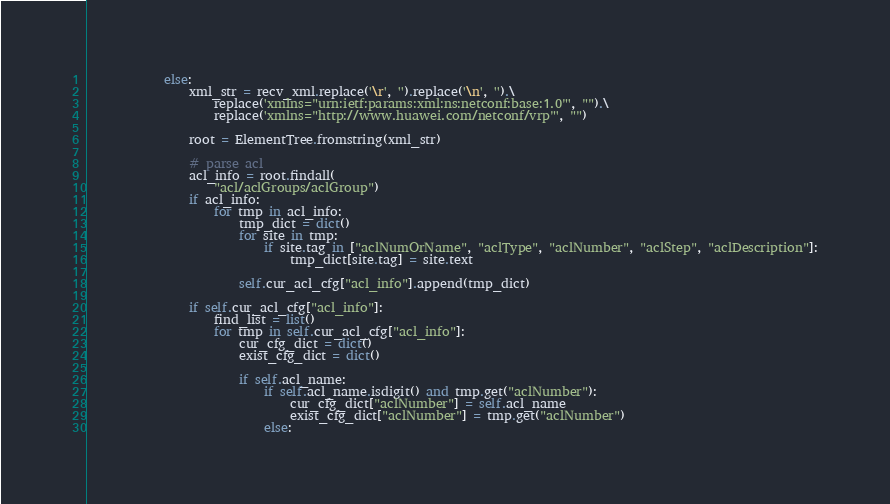Convert code to text. <code><loc_0><loc_0><loc_500><loc_500><_Python_>            else:
                xml_str = recv_xml.replace('\r', '').replace('\n', '').\
                    replace('xmlns="urn:ietf:params:xml:ns:netconf:base:1.0"', "").\
                    replace('xmlns="http://www.huawei.com/netconf/vrp"', "")

                root = ElementTree.fromstring(xml_str)

                # parse acl
                acl_info = root.findall(
                    "acl/aclGroups/aclGroup")
                if acl_info:
                    for tmp in acl_info:
                        tmp_dict = dict()
                        for site in tmp:
                            if site.tag in ["aclNumOrName", "aclType", "aclNumber", "aclStep", "aclDescription"]:
                                tmp_dict[site.tag] = site.text

                        self.cur_acl_cfg["acl_info"].append(tmp_dict)

                if self.cur_acl_cfg["acl_info"]:
                    find_list = list()
                    for tmp in self.cur_acl_cfg["acl_info"]:
                        cur_cfg_dict = dict()
                        exist_cfg_dict = dict()

                        if self.acl_name:
                            if self.acl_name.isdigit() and tmp.get("aclNumber"):
                                cur_cfg_dict["aclNumber"] = self.acl_name
                                exist_cfg_dict["aclNumber"] = tmp.get("aclNumber")
                            else:</code> 